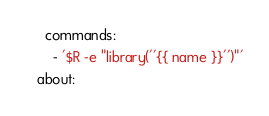<code> <loc_0><loc_0><loc_500><loc_500><_YAML_>  commands:
    - '$R -e "library(''{{ name }}'')"'
about:</code> 